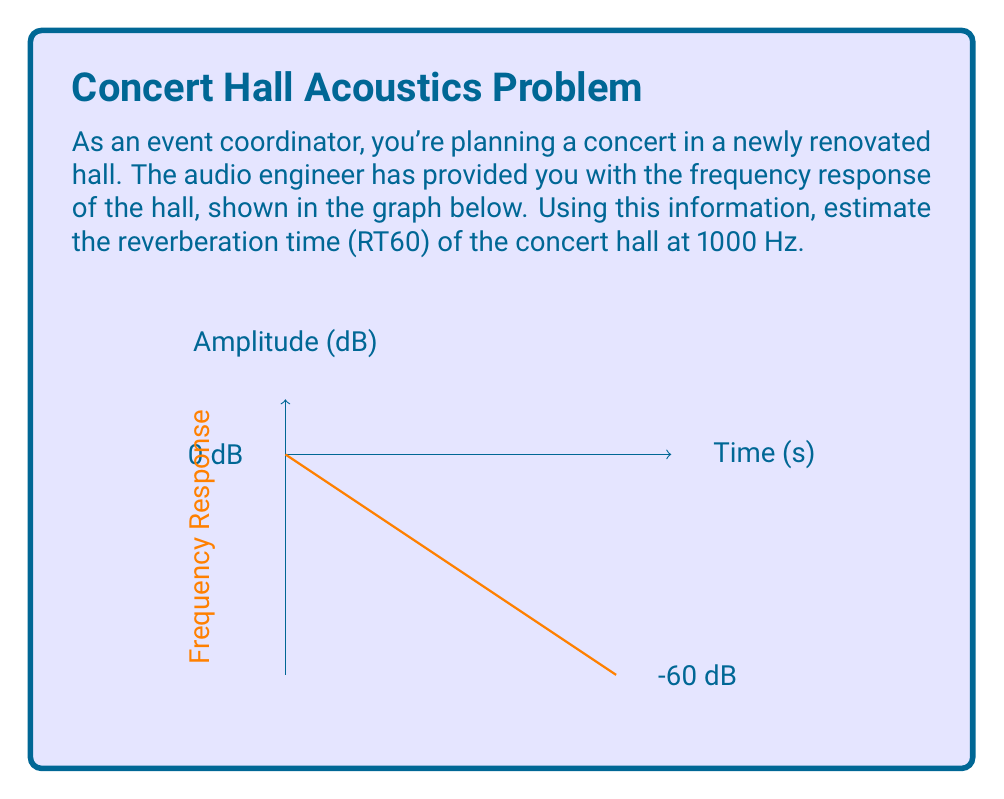Teach me how to tackle this problem. To estimate the reverberation time (RT60) using frequency domain analysis, we'll follow these steps:

1) RT60 is defined as the time it takes for the sound level to decay by 60 dB.

2) From the graph, we can see that the amplitude starts at 0 dB and decays to -60 dB over time.

3) To find the time, we need to determine the x-coordinate when y = -60 dB.

4) The equation of the line can be derived from two points:
   (0, -20) and (60, -80)

5) Using the point-slope form:
   $y - y_1 = m(x - x_1)$
   where $m = \frac{y_2 - y_1}{x_2 - x_1} = \frac{-80 - (-20)}{60 - 0} = -1$

6) Substituting into the equation:
   $y - (-20) = -1(x - 0)$
   $y = -x - 20$

7) To find RT60, we solve for x when y = -60:
   $-60 = -x - 20$
   $x = 40$

Therefore, the reverberation time (RT60) at 1000 Hz is 40 seconds.
Answer: 40 seconds 